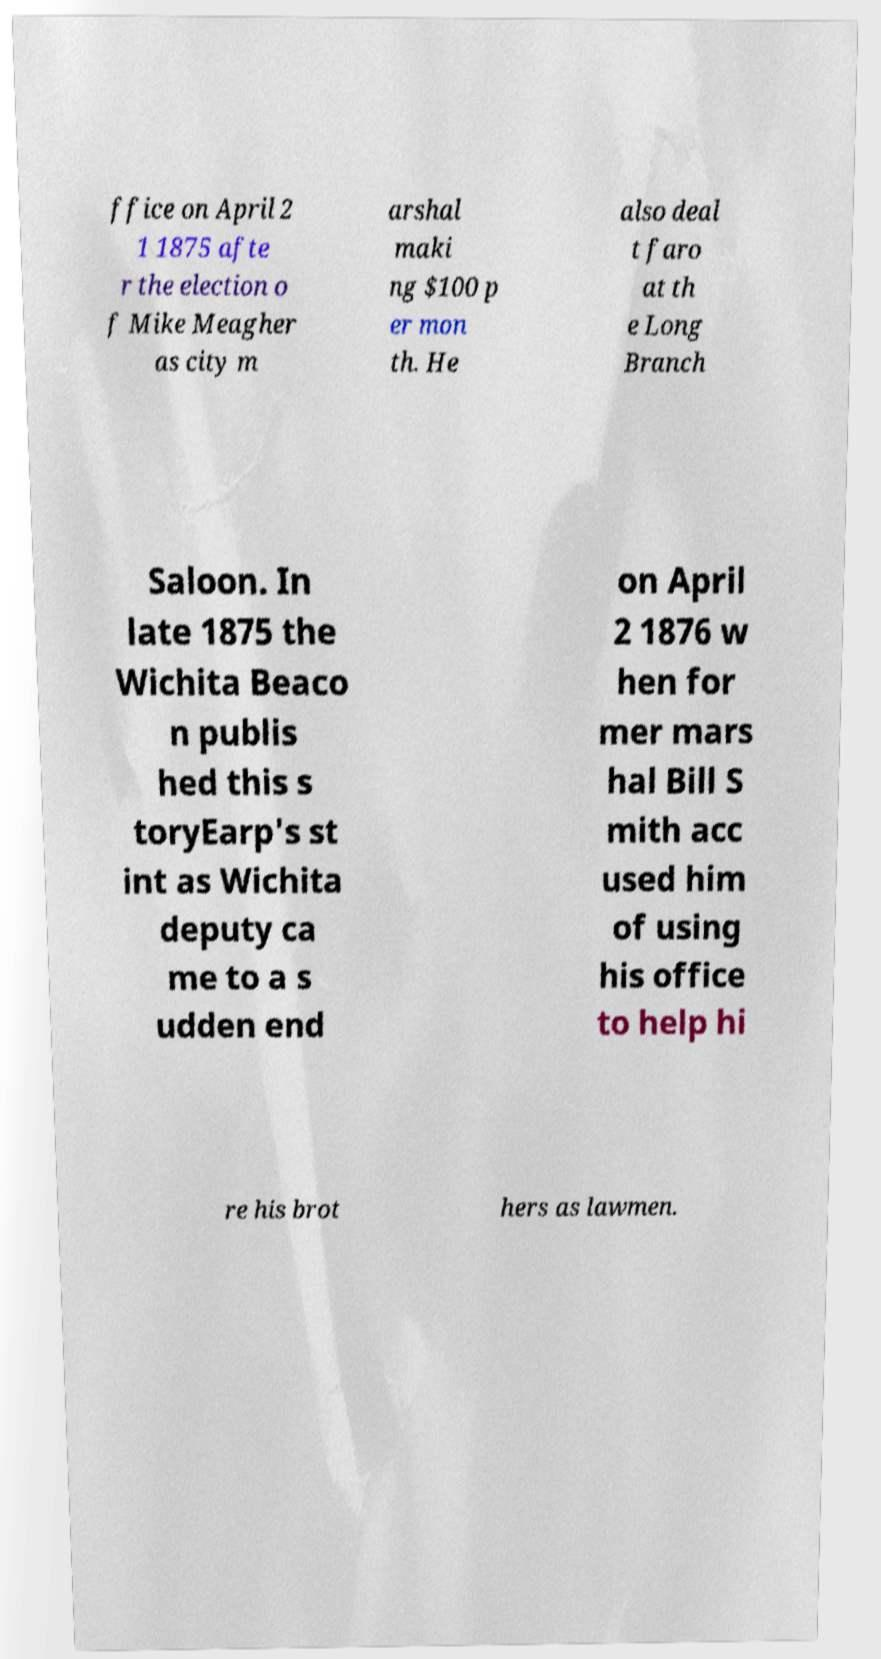What messages or text are displayed in this image? I need them in a readable, typed format. ffice on April 2 1 1875 afte r the election o f Mike Meagher as city m arshal maki ng $100 p er mon th. He also deal t faro at th e Long Branch Saloon. In late 1875 the Wichita Beaco n publis hed this s toryEarp's st int as Wichita deputy ca me to a s udden end on April 2 1876 w hen for mer mars hal Bill S mith acc used him of using his office to help hi re his brot hers as lawmen. 